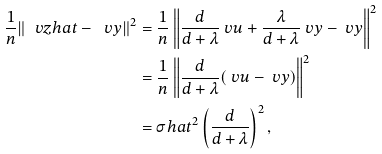Convert formula to latex. <formula><loc_0><loc_0><loc_500><loc_500>\frac { 1 } { n } \| \ v z h a t - \ v y \| ^ { 2 } & = \frac { 1 } { n } \left \| \frac { d } { d + \lambda } \ v u + \frac { \lambda } { d + \lambda } \ v y - \ v y \right \| ^ { 2 } \\ & = \frac { 1 } { n } \left \| \frac { d } { d + \lambda } ( \ v u - \ v y ) \right \| ^ { 2 } \\ & = \sigma h a t ^ { 2 } \left ( \frac { d } { d + \lambda } \right ) ^ { 2 } ,</formula> 